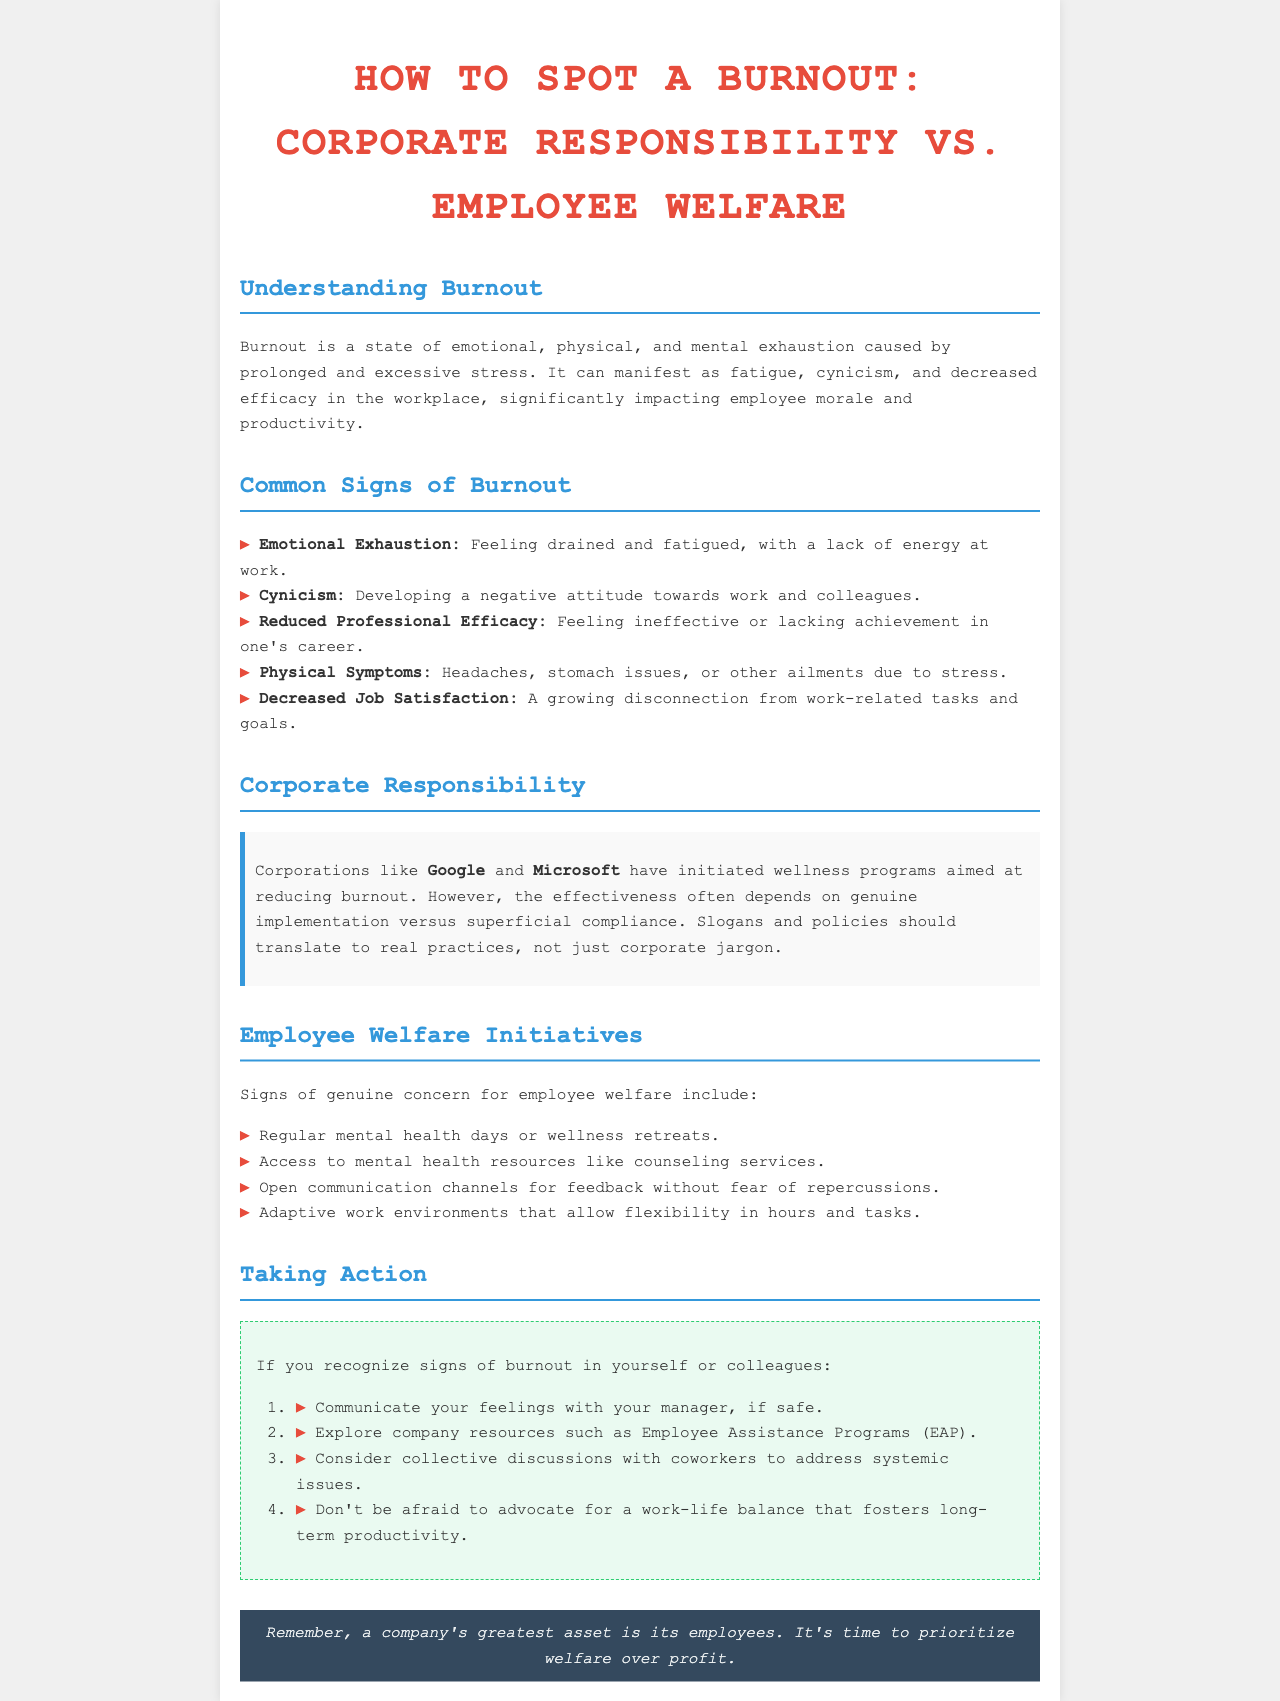what is burnout? Burnout is defined in the document as a state of emotional, physical, and mental exhaustion caused by prolonged and excessive stress.
Answer: emotional, physical, and mental exhaustion name two signs of burnout. The document lists several signs of burnout, two of which are emotional exhaustion and cynicism.
Answer: emotional exhaustion, cynicism what companies are mentioned in relation to corporate responsibility? The document mentions Google and Microsoft in the context of corporate responsibility and wellness programs.
Answer: Google and Microsoft how many action items are listed for addressing burnout? The document provides a list of four action items for addressing burnout.
Answer: four what type of initiatives indicate genuine concern for employee welfare? The document states that regular mental health days and access to mental health resources indicate genuine concern for employee welfare.
Answer: mental health days, access to mental health resources what is suggested for those who recognize signs of burnout in themselves or colleagues? The document suggests that individuals communicate their feelings with their manager, explore company resources, and consider collective discussions.
Answer: communicate feelings, explore resources, collective discussions what is a key aspect of corporate wellness programs mentioned? The document mentions that the effectiveness of corporate wellness programs depends on genuine implementation rather than superficial compliance.
Answer: genuine implementation what is stated as a company's greatest asset? The document emphasizes that a company's greatest asset is its employees.
Answer: employees 